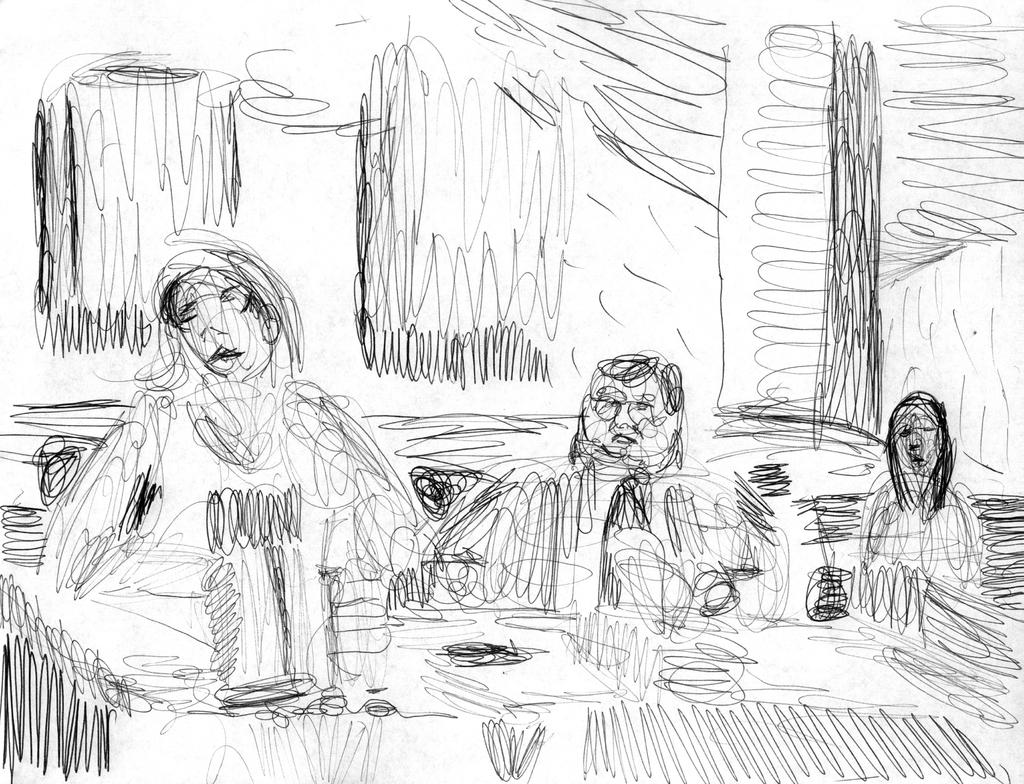What type of drawings are present in the image? There are drawings of persons, windows, and other items in the image. Can you describe the drawings of persons in the image? The drawings of persons in the image depict various figures. What other drawings can be seen in the image besides the drawings of persons and windows? There are drawings of other items in the image. How does the pin balance on the edge of the sink in the image? There is no pin or sink present in the image; it only contains drawings of persons, windows, and other items. 